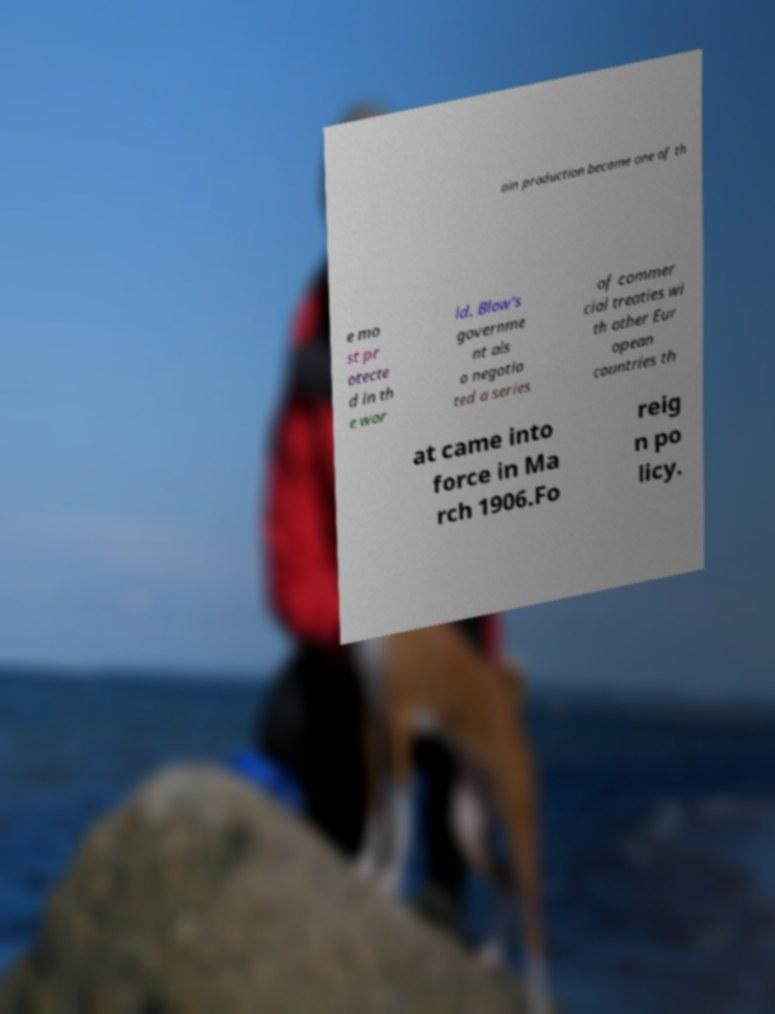There's text embedded in this image that I need extracted. Can you transcribe it verbatim? ain production became one of th e mo st pr otecte d in th e wor ld. Blow's governme nt als o negotia ted a series of commer cial treaties wi th other Eur opean countries th at came into force in Ma rch 1906.Fo reig n po licy. 